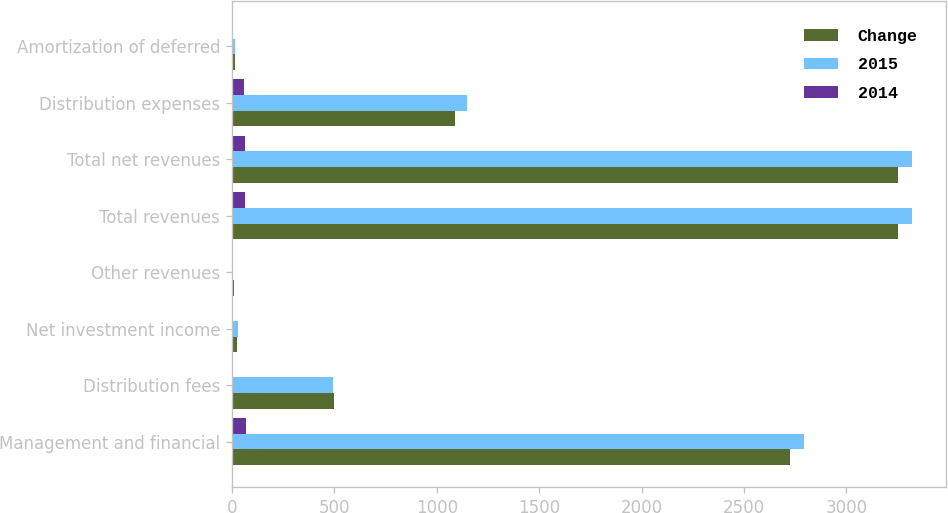Convert chart. <chart><loc_0><loc_0><loc_500><loc_500><stacked_bar_chart><ecel><fcel>Management and financial<fcel>Distribution fees<fcel>Net investment income<fcel>Other revenues<fcel>Total revenues<fcel>Total net revenues<fcel>Distribution expenses<fcel>Amortization of deferred<nl><fcel>Change<fcel>2723<fcel>499<fcel>23<fcel>9<fcel>3254<fcel>3254<fcel>1091<fcel>17<nl><fcel>2015<fcel>2791<fcel>493<fcel>30<fcel>6<fcel>3320<fcel>3320<fcel>1148<fcel>15<nl><fcel>2014<fcel>68<fcel>6<fcel>7<fcel>3<fcel>66<fcel>66<fcel>57<fcel>2<nl></chart> 